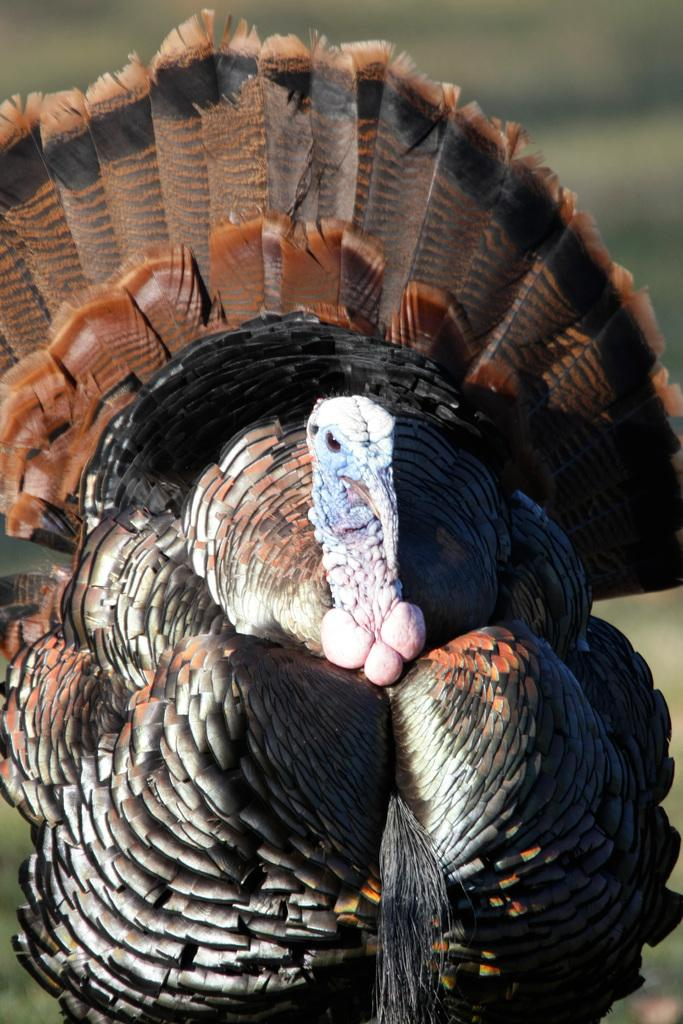What type of animal is present in the image? There is a bird in the image. Can you describe the background of the image? The background of the image is blurred. Is there a lake visible in the image? There is no lake present in the image; it only features a bird and a blurred background. 